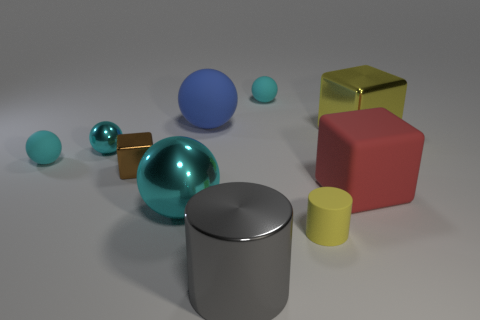There is a big thing that is the same color as the small metal sphere; what is it made of?
Offer a terse response. Metal. There is another metal ball that is the same color as the big shiny ball; what is its size?
Your answer should be very brief. Small. There is a matte object that is the same color as the big shiny cube; what shape is it?
Your answer should be very brief. Cylinder. There is a red matte block; are there any big yellow things to the left of it?
Give a very brief answer. No. Is the number of rubber things that are to the left of the blue thing less than the number of big cylinders?
Your answer should be compact. No. What is the material of the small brown block?
Make the answer very short. Metal. What is the color of the small matte cylinder?
Ensure brevity in your answer.  Yellow. What is the color of the block that is both right of the large gray metal cylinder and left of the yellow metallic thing?
Offer a very short reply. Red. Is there anything else that has the same material as the brown block?
Your response must be concise. Yes. Do the small yellow cylinder and the small cyan sphere that is right of the blue rubber thing have the same material?
Make the answer very short. Yes. 